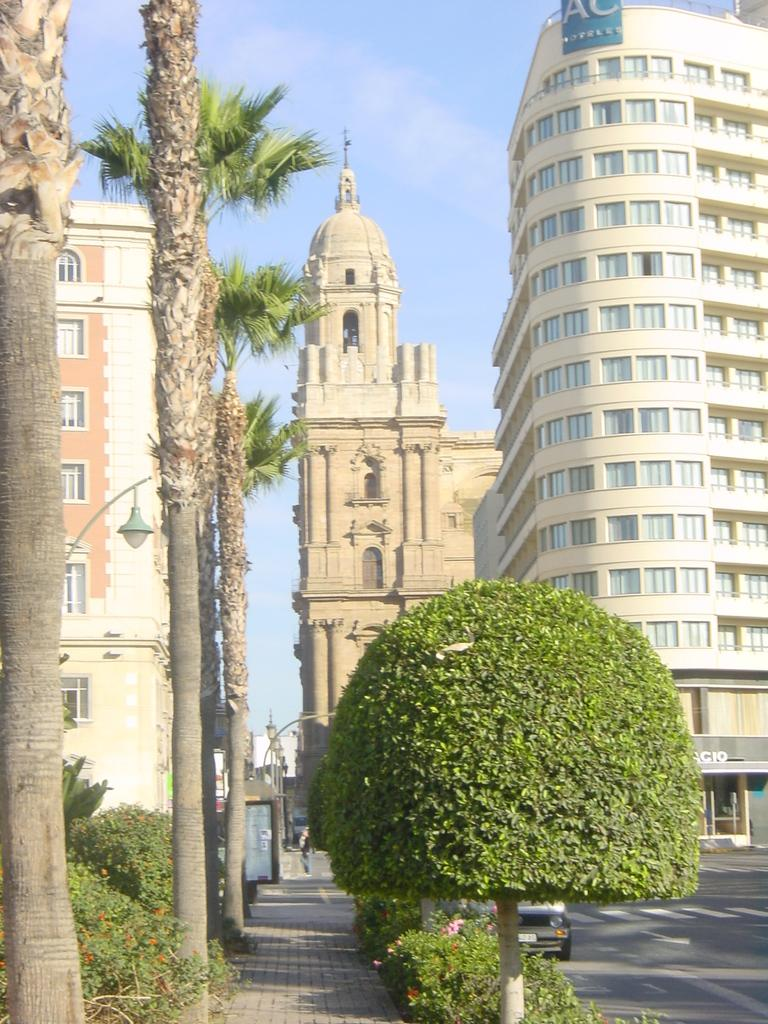What type of structures can be seen in the image? There are buildings in the image. What other natural elements are present in the image? There are plants and trees in the image. Can you describe the vehicle visible in the background of the image? The vehicle is visible in the background of the image, and it is on the road. What part of the natural environment is visible in the image? The sky is visible in the background of the image. What type of offer is being made by the trees in the image? There is no offer being made by the trees in the image, as trees do not make offers. Can you compare the size of the buildings to the size of the trees in the image? The provided facts do not include information about the size of the buildings or trees, so it is not possible to make a comparison. 